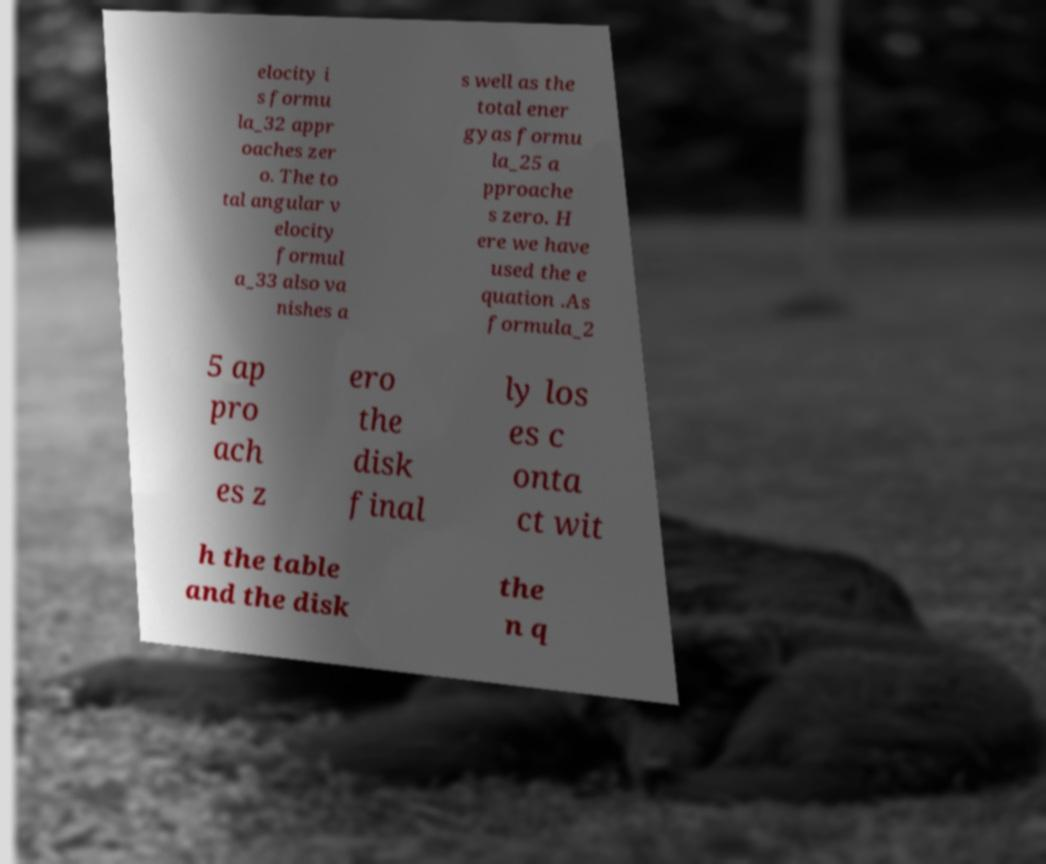There's text embedded in this image that I need extracted. Can you transcribe it verbatim? elocity i s formu la_32 appr oaches zer o. The to tal angular v elocity formul a_33 also va nishes a s well as the total ener gyas formu la_25 a pproache s zero. H ere we have used the e quation .As formula_2 5 ap pro ach es z ero the disk final ly los es c onta ct wit h the table and the disk the n q 